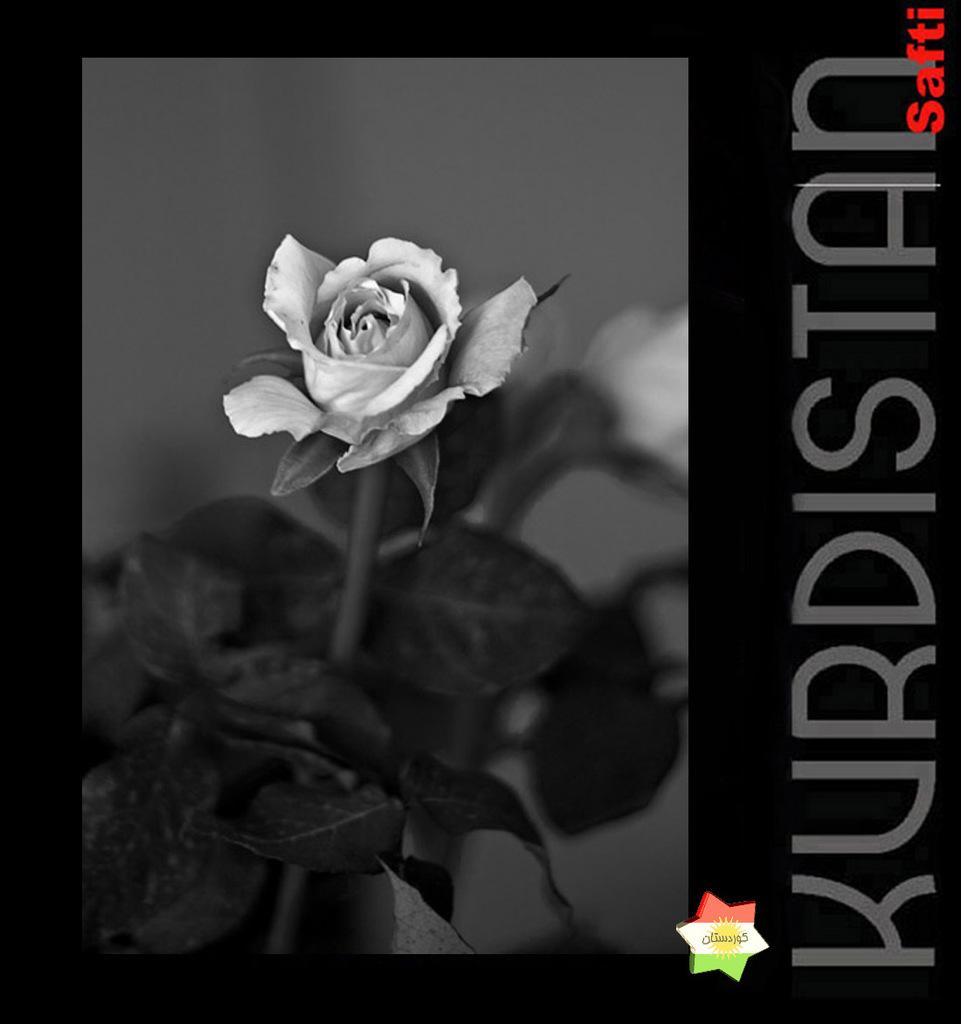What type of plant is visible in the image? There are flowers on the stem of a plant in the image. Have the flowers been altered in any way? Yes, the flowers have been edited. What else can be seen in the image besides the plant? There is text present on the image. What type of alarm can be heard in the image? There is: There is no alarm present in the image; it is a still image of a plant with edited flowers and text. 